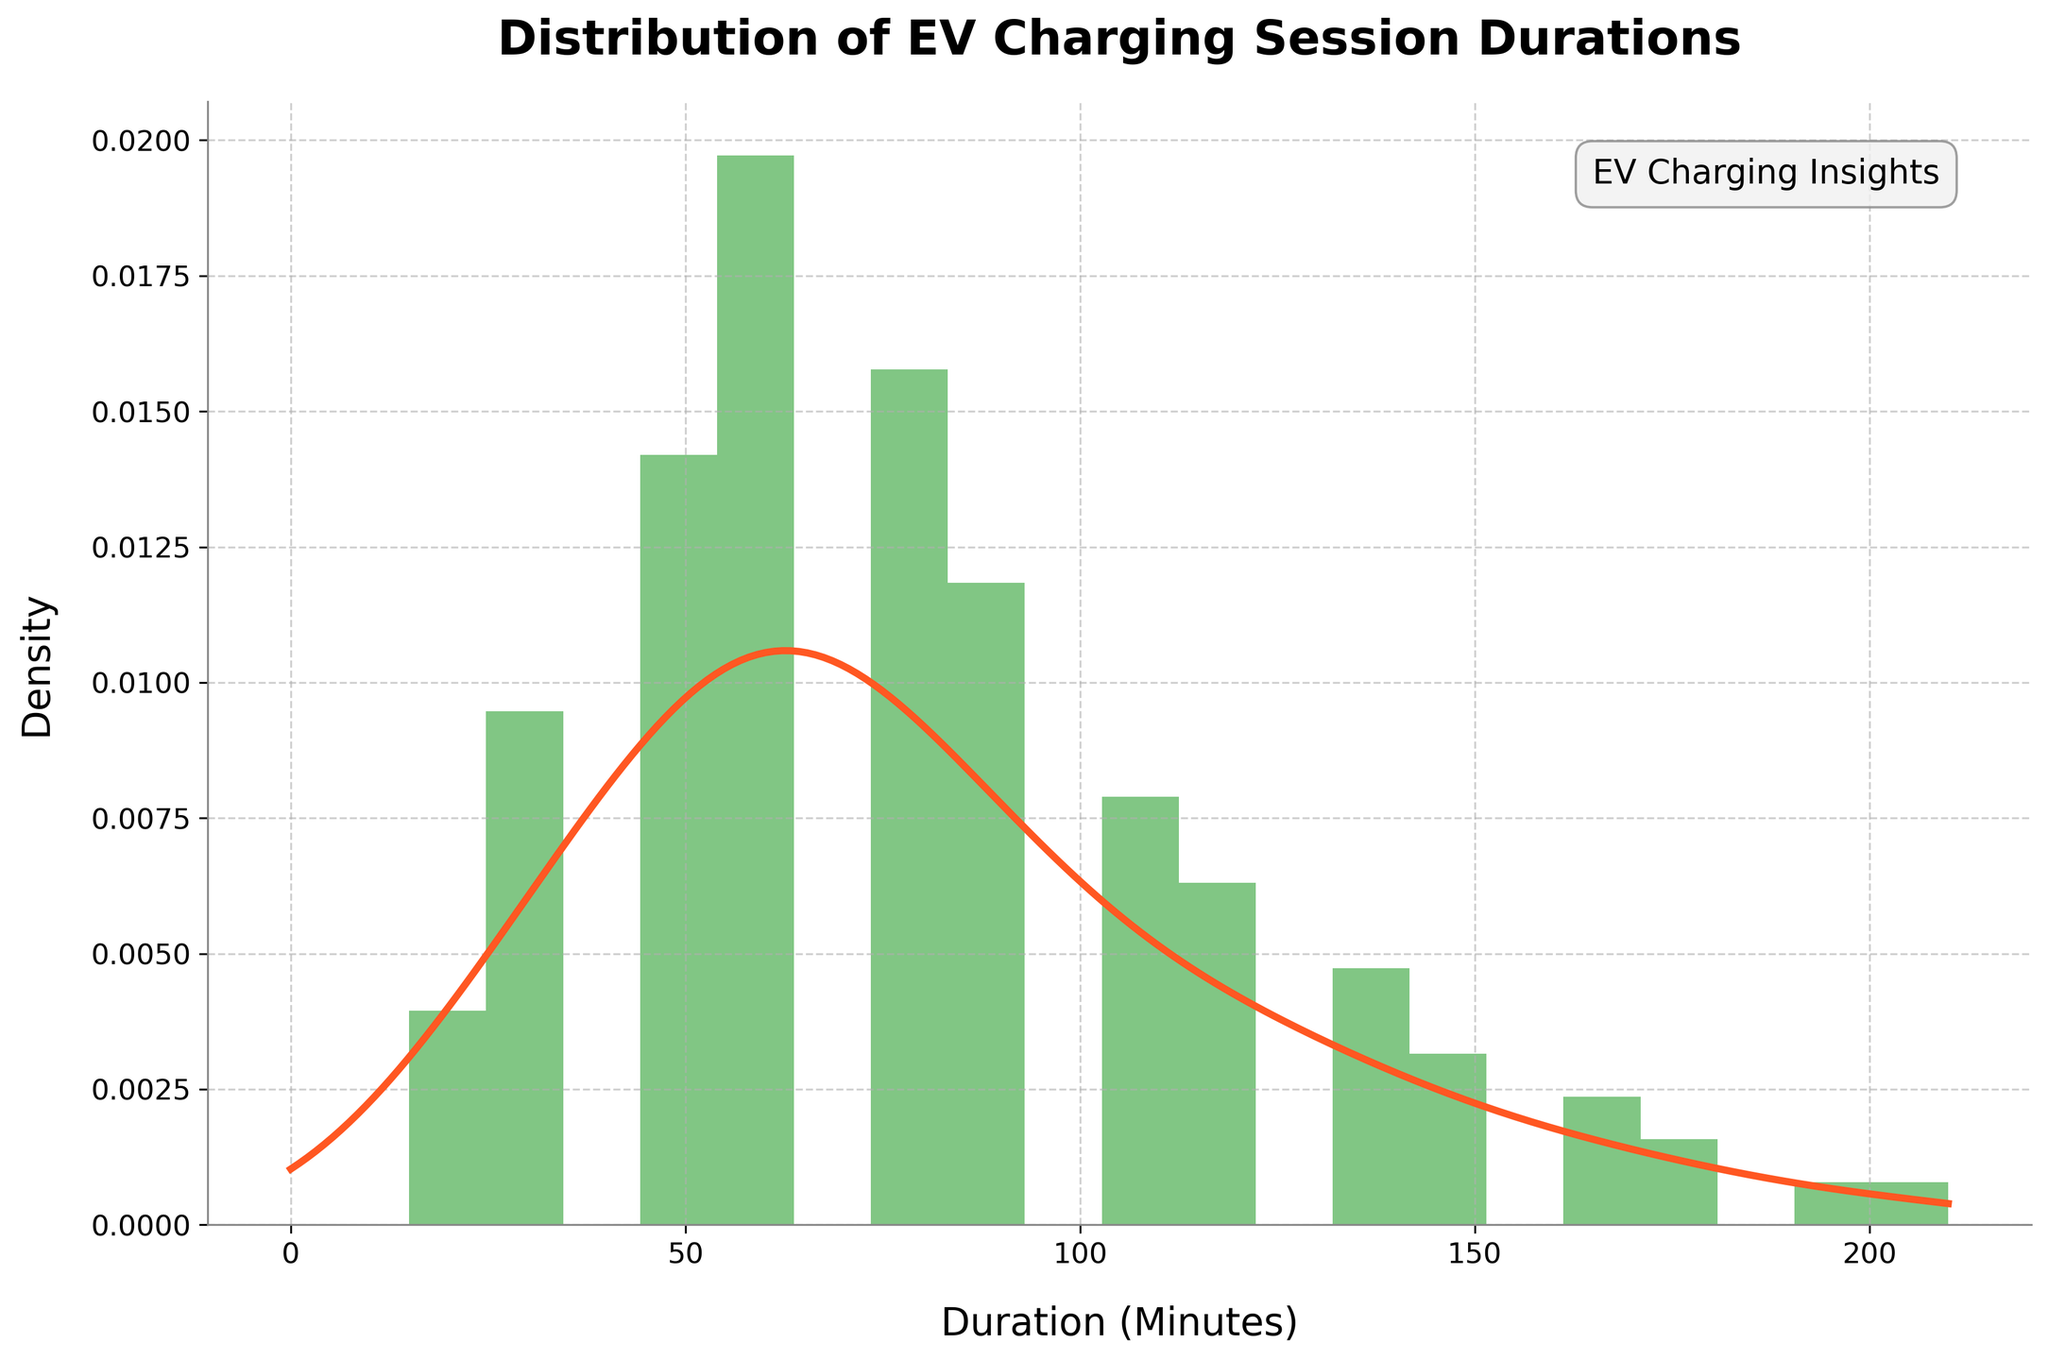What is the title of the figure? The title is located at the top of the figure and it summarizes what the chart is about. It reads "Distribution of EV Charging Session Durations."
Answer: Distribution of EV Charging Session Durations What does the x-axis represent? The x-axis label is placed horizontally at the bottom part of the figure. It reads "Duration (Minutes)," indicating that the x-axis represents the duration of charging sessions in minutes.
Answer: Duration (Minutes) What range of durations is covered in the histogram? By examining the spread of the bins along the x-axis, the histogram spans from 0 to around 210 minutes, as indicated by the x-axis ticks and bin placement.
Answer: 0 to 210 minutes Which duration has the highest density according to the histogram? The highest density peak on the histogram bar plot, combined with the KDE curve apex, occurs at the duration where the y-axis (density) is maximal. This peak appears at approximately 60 minutes.
Answer: Approximately 60 minutes How many frequencies contribute to the bin at 75 minutes? According to the provided data listing individual frequencies per duration, the frequency at 75 minutes is 20. This means 20 sessions lasted 75 minutes.
Answer: 20 What is the shape of the density curve? Observing the density curve plotted over the histogram, it has a smooth, unimodal appearance with a clear peak and tails off as it moves towards higher durations. This reflects the KDE's smoothed representation of the data's probability density function.
Answer: Unimodal and smooth Is there a noticeable skew in the data distribution? The KDE curve and histogram indicate that most charging sessions are shorter rather than longer, concentrated more towards the left side of the plot with a tail extending to the right, suggesting a right skew.
Answer: Right skew What is the combined frequency for charging sessions between 90 and 120 minutes? Referring to the frequency data for durations 90, 105, and 120 minutes, we sum these values: 15 (90 mins) + 10 (105 mins) + 8 (120 mins) = 33.
Answer: 33 Which duration has a lower density: 150 minutes or 180 minutes? By comparing the y-axis values for density at these two durations on the KDE curve, 180 minutes has a lower density than 150 minutes.
Answer: 180 minutes 